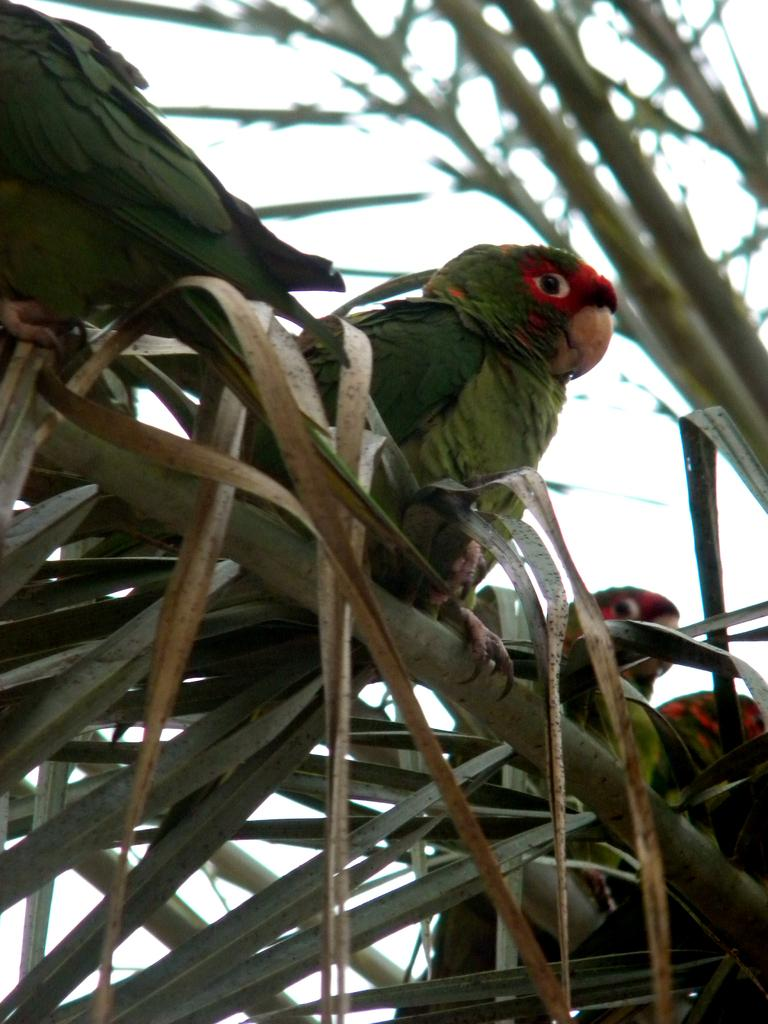What type of animals are in the image? There are parrots in the image. Where are the parrots located in the image? The parrots are standing on a tree. What type of advice can be heard from the parrots in the image? There is no indication in the parrots are giving advice in the image, as they are simply standing on a tree. 